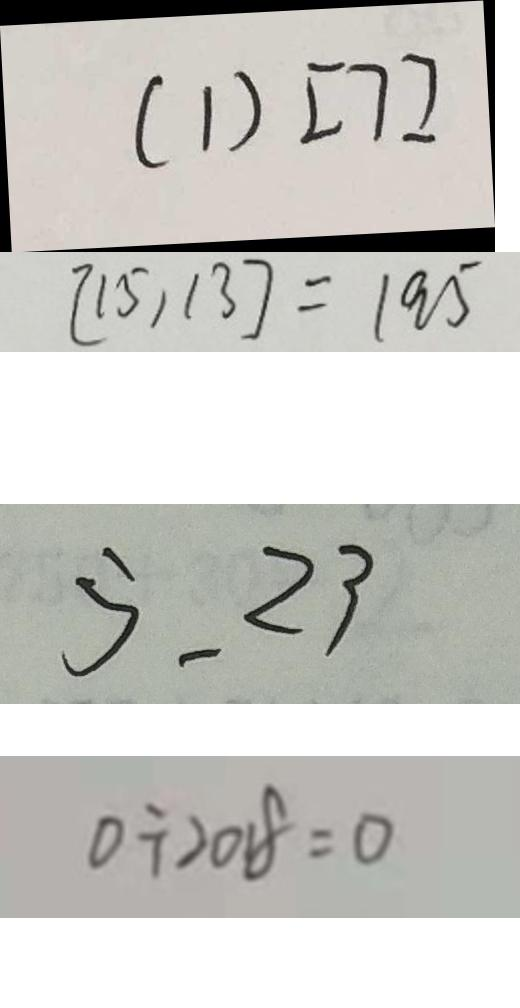<formula> <loc_0><loc_0><loc_500><loc_500>( 1 ) [ 7 ] 
 [ 1 5 , 1 3 ] = 1 9 5 
 5 . 2 3 
 0 \div 2 0 1 8 = 0</formula> 